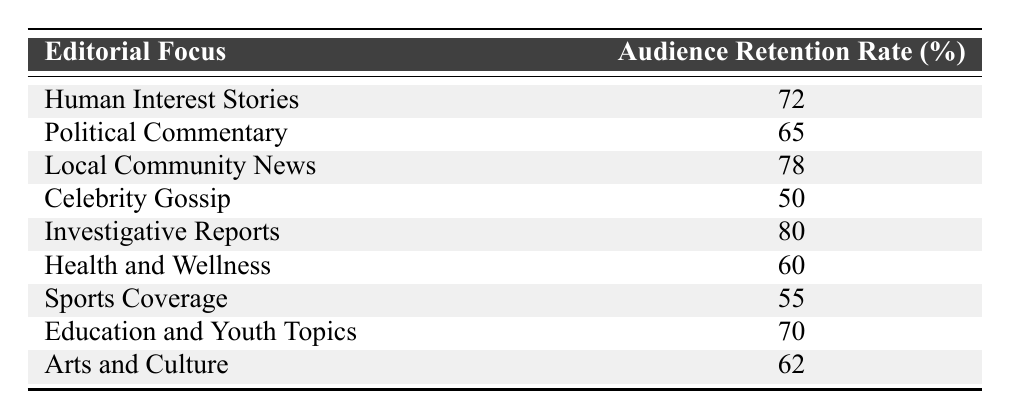What is the audience retention rate for Investigative Reports? The table shows that the audience retention rate specifically for Investigative Reports is 80%.
Answer: 80 Which editorial focus has the lowest audience retention rate? By reviewing the table, it is clear that Celebrity Gossip has the lowest audience retention rate at 50%.
Answer: 50 What is the average audience retention rate for Human Interest Stories and Local Community News? The retention rates for these focuses are 72% and 78%, respectively. To find the average, we add these two numbers: 72 + 78 = 150, then divide by 2 to get 150/2 = 75.
Answer: 75 Is the audience retention rate for Health and Wellness greater than 65%? According to the table, the audience retention rate for Health and Wellness is 60%, which is less than 65%. Therefore, this statement is false.
Answer: No What is the total audience retention rate for all editorial focuses? To find the total retention rate, we need to sum all the audience retention rates from the table: 72 + 65 + 78 + 50 + 80 + 60 + 55 + 70 + 62 = 752.
Answer: 752 Which editorial focus has a higher retention rate: Sports Coverage or Celebrity Gossip? The table shows that Sports Coverage has a retention rate of 55% while Celebrity Gossip has 50%. Since 55% is greater than 50%, Sports Coverage has a higher retention rate.
Answer: Sports Coverage What is the difference in audience retention rates between Local Community News and Arts and Culture? The audience retention rate for Local Community News is 78%, and for Arts and Culture, it is 62%. The difference is calculated by subtracting: 78 - 62 = 16.
Answer: 16 Are there more editorial focuses with retention rates above 70% than below 60%? The editorial focuses with rates above 70% are Human Interest Stories (72), Local Community News (78), and Investigative Reports (80). Those below 60% are Celebrity Gossip (50) and Sports Coverage (55). So, there are 3 above 70% and 2 below 60%. Therefore, the answer is yes.
Answer: Yes What is the highest retention rate among the editorial focuses listed? Investigative Reports has the highest retention rate of 80% from the table.
Answer: 80 